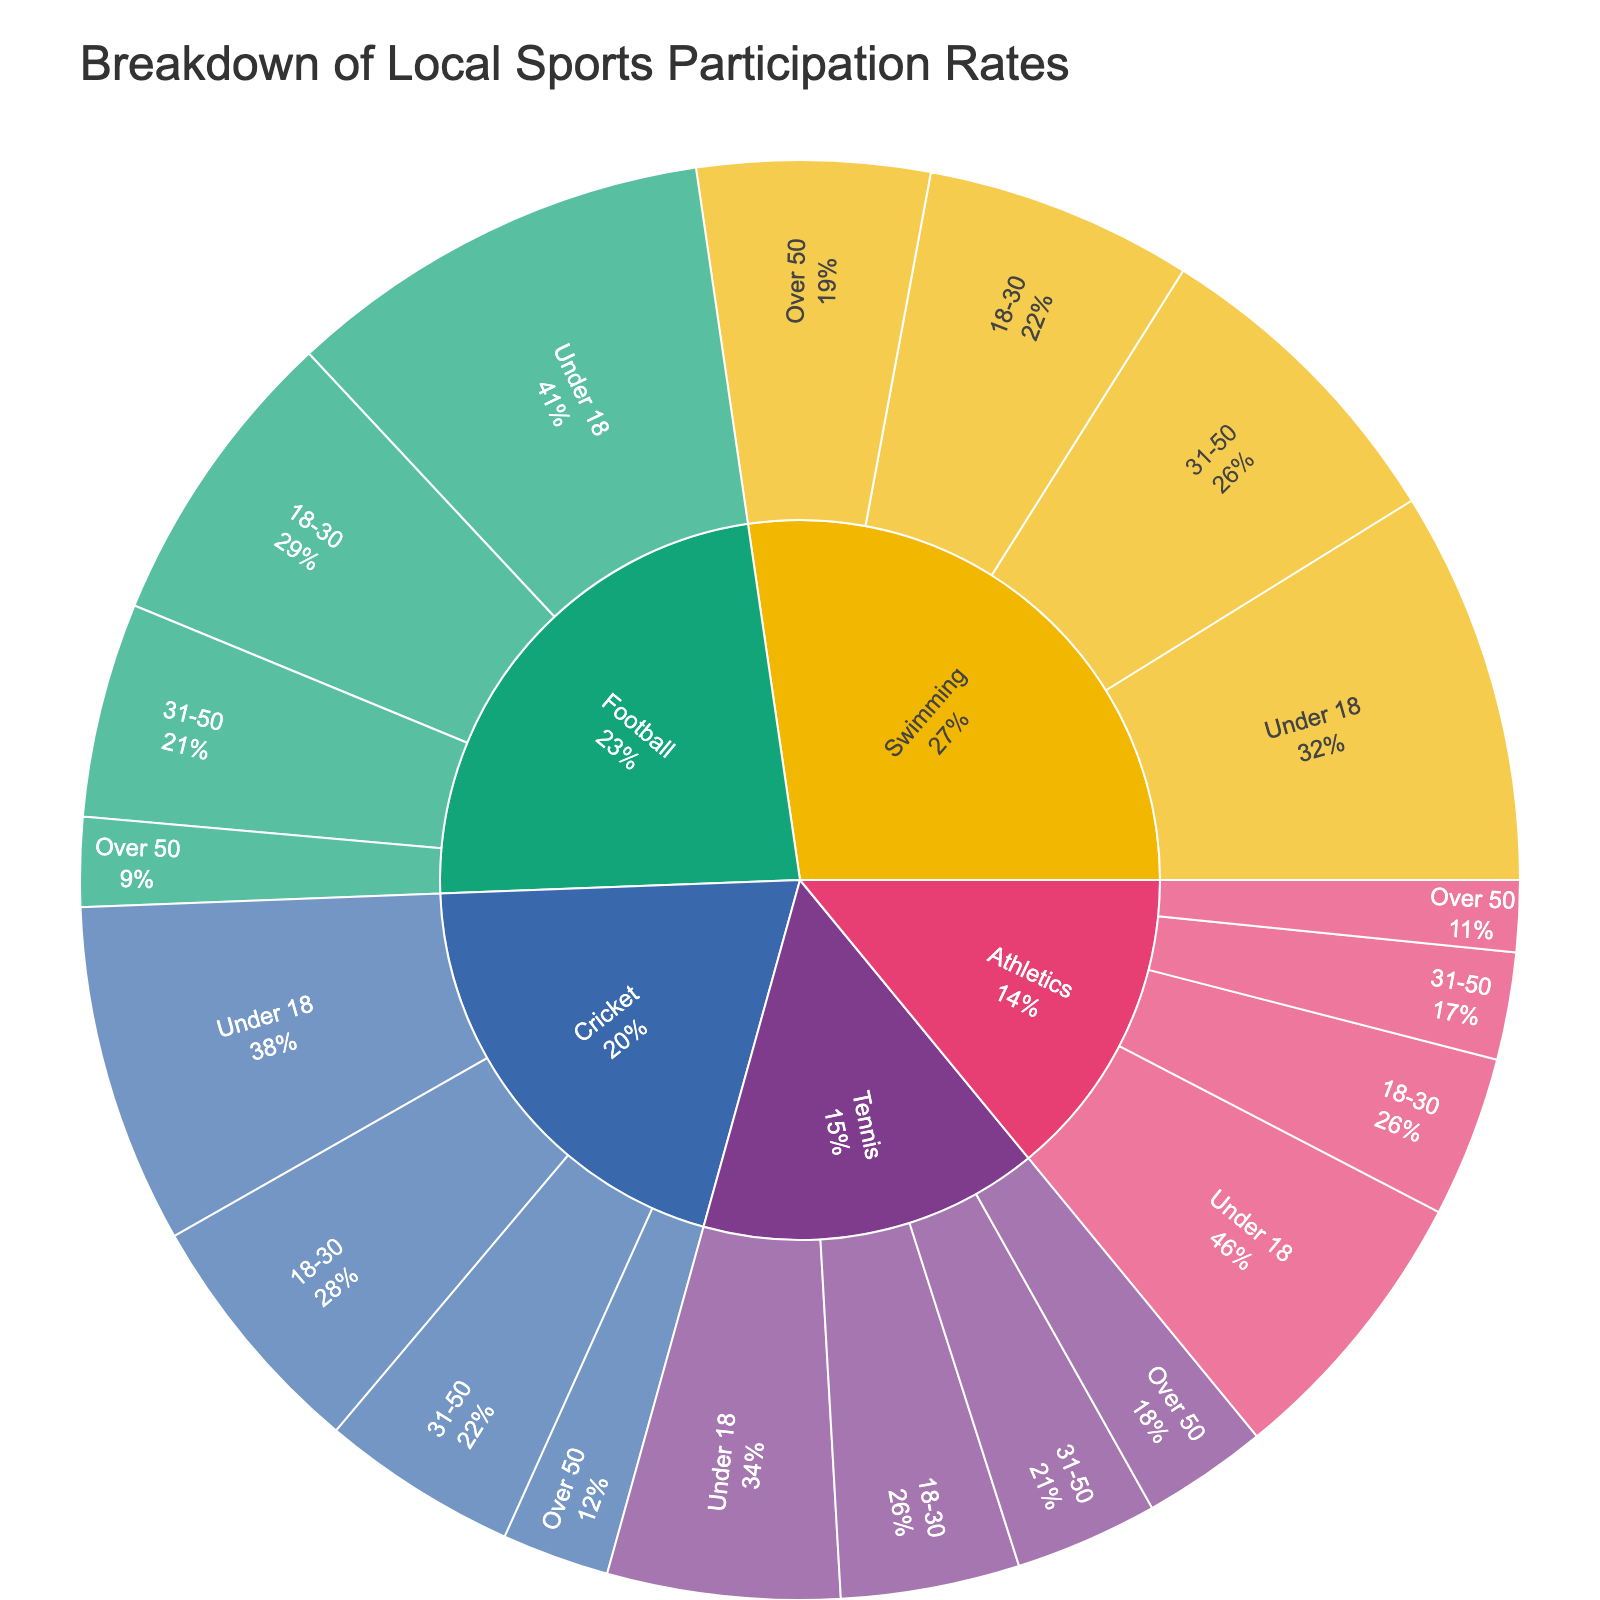What is the title of the plot? The title is usually displayed at the top of the plot and summarizes the main idea of the visualization. For this Sunburst Plot, it should indicate what the figure is about.
Answer: Breakdown of Local Sports Participation Rates Which sport has the highest participation rate for the Under 18 age group? To determine this, look at the sections of the Sunburst Plot under the 'Under 18' category and compare their sizes. The largest segment represents the highest participation rate.
Answer: Football How many total participants are there in the Over 50 age group across all sports? Add the participation numbers for each sport in the Over 50 age group: Football (25) + Cricket (30) + Tennis (35) + Swimming (65) + Athletics (20).
Answer: 175 Between Swimming and Athletics, which sport has more participants in the 31-50 age group? Compare the sizes of the segments for Swimming and Athletics within the 31-50 age group category. The larger segment indicates the sport with more participants.
Answer: Swimming What percentage of total Football participants are in the 18-30 age group? Calculate the proportion of participants in the 18-30 age group relative to the total number of Football participants. (85 / (120 + 85 + 60 + 25)) * 100 = (85 / 290) * 100.
Answer: 29.3% Which age group has the lowest participation rate for Cricket? Compare the different age group segments within the Cricket category. The smallest segment represents the age group with the lowest participation rate.
Answer: 31-50 Are there more Tennis participants in the Under 18 group or the 31-50 group? Compare the sizes of the Tennis segments for the Under 18 and 31-50 age groups. The larger segment indicates the higher participation rate.
Answer: Under 18 How does the participation rate of Athletics for the 18-30 age group compare to that of Tennis for the same age group? Compare the sizes of the segments representing the 18-30 age group for Athletics and Tennis. Since these segments indicate participation, the one with the greater size has a higher participation rate.
Answer: Athletics has fewer participants Which sport has the greatest distribution of participants across all age groups? This involves looking at the balance of segment sizes for each sport across different age groups. The sport with the most even distribution of segment sizes across its different age groups would have the greatest distribution.
Answer: Swimming How many total participants are there for Swimming across all age groups? Add the participation numbers for each age group in Swimming: Under 18 (110) + 18-30 (75) + 31-50 (90) + Over 50 (65).
Answer: 340 